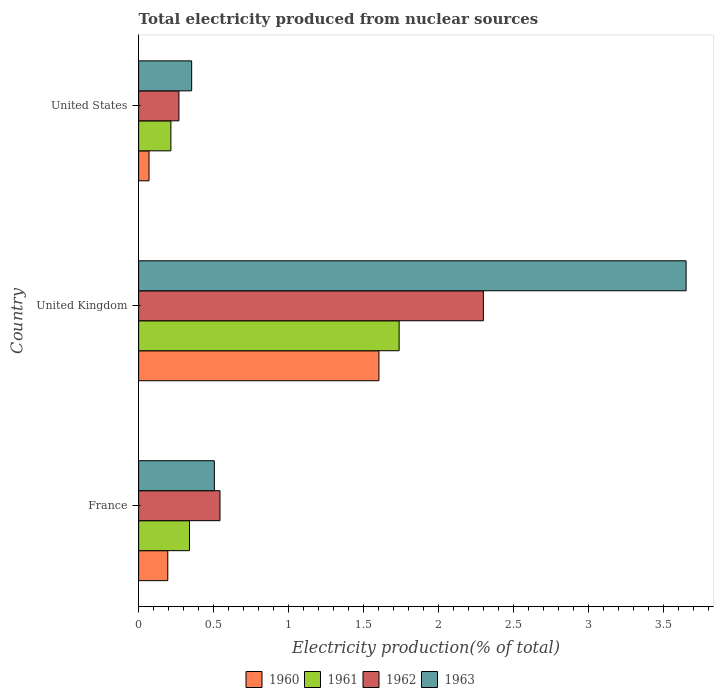How many different coloured bars are there?
Give a very brief answer. 4. How many groups of bars are there?
Your response must be concise. 3. What is the label of the 1st group of bars from the top?
Your answer should be compact. United States. In how many cases, is the number of bars for a given country not equal to the number of legend labels?
Ensure brevity in your answer.  0. What is the total electricity produced in 1962 in France?
Provide a short and direct response. 0.54. Across all countries, what is the maximum total electricity produced in 1960?
Provide a short and direct response. 1.6. Across all countries, what is the minimum total electricity produced in 1960?
Your response must be concise. 0.07. In which country was the total electricity produced in 1960 maximum?
Keep it short and to the point. United Kingdom. What is the total total electricity produced in 1962 in the graph?
Your answer should be compact. 3.11. What is the difference between the total electricity produced in 1962 in United Kingdom and that in United States?
Your answer should be compact. 2.03. What is the difference between the total electricity produced in 1960 in United States and the total electricity produced in 1961 in France?
Give a very brief answer. -0.27. What is the average total electricity produced in 1960 per country?
Provide a succinct answer. 0.62. What is the difference between the total electricity produced in 1961 and total electricity produced in 1960 in France?
Your response must be concise. 0.14. What is the ratio of the total electricity produced in 1962 in United Kingdom to that in United States?
Ensure brevity in your answer.  8.56. Is the total electricity produced in 1963 in United Kingdom less than that in United States?
Ensure brevity in your answer.  No. What is the difference between the highest and the second highest total electricity produced in 1963?
Provide a succinct answer. 3.15. What is the difference between the highest and the lowest total electricity produced in 1961?
Offer a very short reply. 1.52. Is it the case that in every country, the sum of the total electricity produced in 1960 and total electricity produced in 1961 is greater than the total electricity produced in 1963?
Keep it short and to the point. No. How many bars are there?
Offer a terse response. 12. Are all the bars in the graph horizontal?
Give a very brief answer. Yes. What is the difference between two consecutive major ticks on the X-axis?
Make the answer very short. 0.5. Are the values on the major ticks of X-axis written in scientific E-notation?
Ensure brevity in your answer.  No. Where does the legend appear in the graph?
Keep it short and to the point. Bottom center. What is the title of the graph?
Your answer should be very brief. Total electricity produced from nuclear sources. Does "2005" appear as one of the legend labels in the graph?
Your response must be concise. No. What is the label or title of the Y-axis?
Provide a succinct answer. Country. What is the Electricity production(% of total) of 1960 in France?
Ensure brevity in your answer.  0.19. What is the Electricity production(% of total) in 1961 in France?
Your response must be concise. 0.34. What is the Electricity production(% of total) of 1962 in France?
Give a very brief answer. 0.54. What is the Electricity production(% of total) in 1963 in France?
Offer a very short reply. 0.51. What is the Electricity production(% of total) of 1960 in United Kingdom?
Keep it short and to the point. 1.6. What is the Electricity production(% of total) of 1961 in United Kingdom?
Provide a short and direct response. 1.74. What is the Electricity production(% of total) of 1962 in United Kingdom?
Keep it short and to the point. 2.3. What is the Electricity production(% of total) in 1963 in United Kingdom?
Your response must be concise. 3.65. What is the Electricity production(% of total) in 1960 in United States?
Your response must be concise. 0.07. What is the Electricity production(% of total) in 1961 in United States?
Offer a terse response. 0.22. What is the Electricity production(% of total) of 1962 in United States?
Your response must be concise. 0.27. What is the Electricity production(% of total) of 1963 in United States?
Provide a succinct answer. 0.35. Across all countries, what is the maximum Electricity production(% of total) in 1960?
Offer a terse response. 1.6. Across all countries, what is the maximum Electricity production(% of total) of 1961?
Make the answer very short. 1.74. Across all countries, what is the maximum Electricity production(% of total) of 1962?
Make the answer very short. 2.3. Across all countries, what is the maximum Electricity production(% of total) in 1963?
Offer a very short reply. 3.65. Across all countries, what is the minimum Electricity production(% of total) in 1960?
Provide a short and direct response. 0.07. Across all countries, what is the minimum Electricity production(% of total) in 1961?
Keep it short and to the point. 0.22. Across all countries, what is the minimum Electricity production(% of total) of 1962?
Give a very brief answer. 0.27. Across all countries, what is the minimum Electricity production(% of total) of 1963?
Ensure brevity in your answer.  0.35. What is the total Electricity production(% of total) of 1960 in the graph?
Provide a short and direct response. 1.87. What is the total Electricity production(% of total) in 1961 in the graph?
Provide a short and direct response. 2.29. What is the total Electricity production(% of total) of 1962 in the graph?
Give a very brief answer. 3.11. What is the total Electricity production(% of total) of 1963 in the graph?
Your response must be concise. 4.51. What is the difference between the Electricity production(% of total) in 1960 in France and that in United Kingdom?
Offer a terse response. -1.41. What is the difference between the Electricity production(% of total) of 1961 in France and that in United Kingdom?
Your response must be concise. -1.4. What is the difference between the Electricity production(% of total) of 1962 in France and that in United Kingdom?
Offer a very short reply. -1.76. What is the difference between the Electricity production(% of total) of 1963 in France and that in United Kingdom?
Ensure brevity in your answer.  -3.15. What is the difference between the Electricity production(% of total) in 1960 in France and that in United States?
Give a very brief answer. 0.13. What is the difference between the Electricity production(% of total) of 1961 in France and that in United States?
Your answer should be compact. 0.12. What is the difference between the Electricity production(% of total) in 1962 in France and that in United States?
Provide a short and direct response. 0.27. What is the difference between the Electricity production(% of total) of 1963 in France and that in United States?
Provide a short and direct response. 0.15. What is the difference between the Electricity production(% of total) of 1960 in United Kingdom and that in United States?
Provide a succinct answer. 1.53. What is the difference between the Electricity production(% of total) in 1961 in United Kingdom and that in United States?
Your answer should be compact. 1.52. What is the difference between the Electricity production(% of total) of 1962 in United Kingdom and that in United States?
Offer a terse response. 2.03. What is the difference between the Electricity production(% of total) of 1963 in United Kingdom and that in United States?
Offer a terse response. 3.3. What is the difference between the Electricity production(% of total) of 1960 in France and the Electricity production(% of total) of 1961 in United Kingdom?
Keep it short and to the point. -1.54. What is the difference between the Electricity production(% of total) in 1960 in France and the Electricity production(% of total) in 1962 in United Kingdom?
Provide a succinct answer. -2.11. What is the difference between the Electricity production(% of total) of 1960 in France and the Electricity production(% of total) of 1963 in United Kingdom?
Your answer should be very brief. -3.46. What is the difference between the Electricity production(% of total) of 1961 in France and the Electricity production(% of total) of 1962 in United Kingdom?
Give a very brief answer. -1.96. What is the difference between the Electricity production(% of total) of 1961 in France and the Electricity production(% of total) of 1963 in United Kingdom?
Your answer should be very brief. -3.31. What is the difference between the Electricity production(% of total) of 1962 in France and the Electricity production(% of total) of 1963 in United Kingdom?
Provide a short and direct response. -3.11. What is the difference between the Electricity production(% of total) of 1960 in France and the Electricity production(% of total) of 1961 in United States?
Offer a very short reply. -0.02. What is the difference between the Electricity production(% of total) of 1960 in France and the Electricity production(% of total) of 1962 in United States?
Your answer should be compact. -0.07. What is the difference between the Electricity production(% of total) in 1960 in France and the Electricity production(% of total) in 1963 in United States?
Provide a succinct answer. -0.16. What is the difference between the Electricity production(% of total) of 1961 in France and the Electricity production(% of total) of 1962 in United States?
Ensure brevity in your answer.  0.07. What is the difference between the Electricity production(% of total) in 1961 in France and the Electricity production(% of total) in 1963 in United States?
Ensure brevity in your answer.  -0.01. What is the difference between the Electricity production(% of total) in 1962 in France and the Electricity production(% of total) in 1963 in United States?
Offer a terse response. 0.19. What is the difference between the Electricity production(% of total) in 1960 in United Kingdom and the Electricity production(% of total) in 1961 in United States?
Your response must be concise. 1.39. What is the difference between the Electricity production(% of total) in 1960 in United Kingdom and the Electricity production(% of total) in 1962 in United States?
Your answer should be very brief. 1.33. What is the difference between the Electricity production(% of total) of 1960 in United Kingdom and the Electricity production(% of total) of 1963 in United States?
Keep it short and to the point. 1.25. What is the difference between the Electricity production(% of total) in 1961 in United Kingdom and the Electricity production(% of total) in 1962 in United States?
Your answer should be very brief. 1.47. What is the difference between the Electricity production(% of total) of 1961 in United Kingdom and the Electricity production(% of total) of 1963 in United States?
Offer a very short reply. 1.38. What is the difference between the Electricity production(% of total) of 1962 in United Kingdom and the Electricity production(% of total) of 1963 in United States?
Keep it short and to the point. 1.95. What is the average Electricity production(% of total) in 1960 per country?
Offer a very short reply. 0.62. What is the average Electricity production(% of total) of 1961 per country?
Your answer should be very brief. 0.76. What is the average Electricity production(% of total) of 1962 per country?
Your answer should be compact. 1.04. What is the average Electricity production(% of total) of 1963 per country?
Provide a short and direct response. 1.5. What is the difference between the Electricity production(% of total) in 1960 and Electricity production(% of total) in 1961 in France?
Your response must be concise. -0.14. What is the difference between the Electricity production(% of total) of 1960 and Electricity production(% of total) of 1962 in France?
Your answer should be very brief. -0.35. What is the difference between the Electricity production(% of total) of 1960 and Electricity production(% of total) of 1963 in France?
Your answer should be very brief. -0.31. What is the difference between the Electricity production(% of total) of 1961 and Electricity production(% of total) of 1962 in France?
Ensure brevity in your answer.  -0.2. What is the difference between the Electricity production(% of total) of 1961 and Electricity production(% of total) of 1963 in France?
Give a very brief answer. -0.17. What is the difference between the Electricity production(% of total) of 1962 and Electricity production(% of total) of 1963 in France?
Provide a short and direct response. 0.04. What is the difference between the Electricity production(% of total) in 1960 and Electricity production(% of total) in 1961 in United Kingdom?
Offer a very short reply. -0.13. What is the difference between the Electricity production(% of total) of 1960 and Electricity production(% of total) of 1962 in United Kingdom?
Offer a very short reply. -0.7. What is the difference between the Electricity production(% of total) of 1960 and Electricity production(% of total) of 1963 in United Kingdom?
Keep it short and to the point. -2.05. What is the difference between the Electricity production(% of total) in 1961 and Electricity production(% of total) in 1962 in United Kingdom?
Provide a succinct answer. -0.56. What is the difference between the Electricity production(% of total) of 1961 and Electricity production(% of total) of 1963 in United Kingdom?
Your answer should be very brief. -1.91. What is the difference between the Electricity production(% of total) of 1962 and Electricity production(% of total) of 1963 in United Kingdom?
Ensure brevity in your answer.  -1.35. What is the difference between the Electricity production(% of total) of 1960 and Electricity production(% of total) of 1961 in United States?
Provide a short and direct response. -0.15. What is the difference between the Electricity production(% of total) in 1960 and Electricity production(% of total) in 1962 in United States?
Offer a terse response. -0.2. What is the difference between the Electricity production(% of total) of 1960 and Electricity production(% of total) of 1963 in United States?
Provide a short and direct response. -0.28. What is the difference between the Electricity production(% of total) in 1961 and Electricity production(% of total) in 1962 in United States?
Your answer should be compact. -0.05. What is the difference between the Electricity production(% of total) of 1961 and Electricity production(% of total) of 1963 in United States?
Ensure brevity in your answer.  -0.14. What is the difference between the Electricity production(% of total) of 1962 and Electricity production(% of total) of 1963 in United States?
Keep it short and to the point. -0.09. What is the ratio of the Electricity production(% of total) in 1960 in France to that in United Kingdom?
Your response must be concise. 0.12. What is the ratio of the Electricity production(% of total) in 1961 in France to that in United Kingdom?
Ensure brevity in your answer.  0.2. What is the ratio of the Electricity production(% of total) in 1962 in France to that in United Kingdom?
Your answer should be very brief. 0.24. What is the ratio of the Electricity production(% of total) of 1963 in France to that in United Kingdom?
Keep it short and to the point. 0.14. What is the ratio of the Electricity production(% of total) of 1960 in France to that in United States?
Give a very brief answer. 2.81. What is the ratio of the Electricity production(% of total) in 1961 in France to that in United States?
Provide a succinct answer. 1.58. What is the ratio of the Electricity production(% of total) in 1962 in France to that in United States?
Provide a succinct answer. 2.02. What is the ratio of the Electricity production(% of total) in 1963 in France to that in United States?
Your answer should be compact. 1.43. What is the ratio of the Electricity production(% of total) of 1960 in United Kingdom to that in United States?
Offer a terse response. 23.14. What is the ratio of the Electricity production(% of total) in 1961 in United Kingdom to that in United States?
Your answer should be compact. 8.08. What is the ratio of the Electricity production(% of total) of 1962 in United Kingdom to that in United States?
Keep it short and to the point. 8.56. What is the ratio of the Electricity production(% of total) in 1963 in United Kingdom to that in United States?
Your answer should be very brief. 10.32. What is the difference between the highest and the second highest Electricity production(% of total) of 1960?
Offer a terse response. 1.41. What is the difference between the highest and the second highest Electricity production(% of total) of 1961?
Provide a short and direct response. 1.4. What is the difference between the highest and the second highest Electricity production(% of total) of 1962?
Keep it short and to the point. 1.76. What is the difference between the highest and the second highest Electricity production(% of total) in 1963?
Make the answer very short. 3.15. What is the difference between the highest and the lowest Electricity production(% of total) of 1960?
Your answer should be very brief. 1.53. What is the difference between the highest and the lowest Electricity production(% of total) in 1961?
Provide a short and direct response. 1.52. What is the difference between the highest and the lowest Electricity production(% of total) of 1962?
Your response must be concise. 2.03. What is the difference between the highest and the lowest Electricity production(% of total) of 1963?
Offer a very short reply. 3.3. 